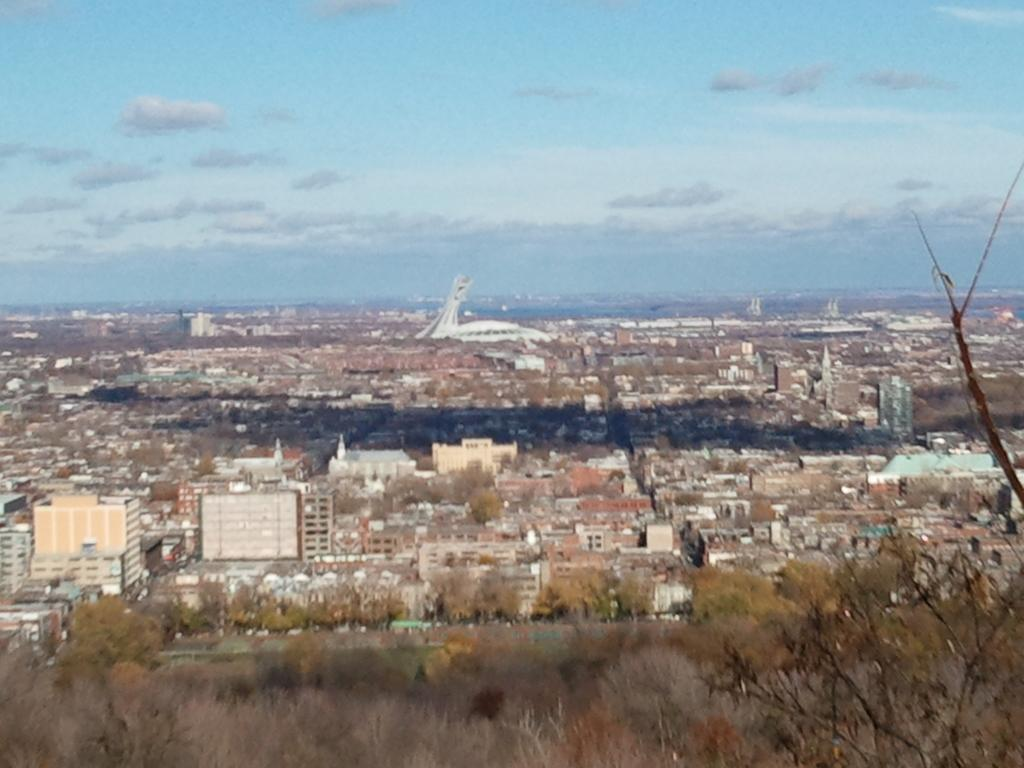What type of location is depicted in the image? The image depicts a city. What structures can be seen in the city? There are buildings and houses in the image. What type of vegetation is present in the city? Trees are present in the image, and grass is visible on the ground. What can be seen in the background of the image? The sky is visible in the background of the image, and there are clouds in the sky. How do the women in the image react to the boat passing by? There are no women or boats present in the image; it depicts a city with buildings, houses, trees, grass, and the sky. 